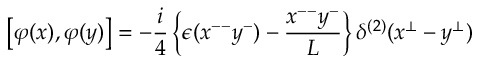Convert formula to latex. <formula><loc_0><loc_0><loc_500><loc_500>\left [ \varphi ( x ) , \varphi ( y ) \right ] = - { \frac { i } { 4 } } \left \{ \epsilon ( x ^ { - - } y ^ { - } ) - { \frac { x ^ { - - } y ^ { - } } { L } } \right \} \delta ^ { ( 2 ) } ( x ^ { \bot } - y ^ { \bot } )</formula> 